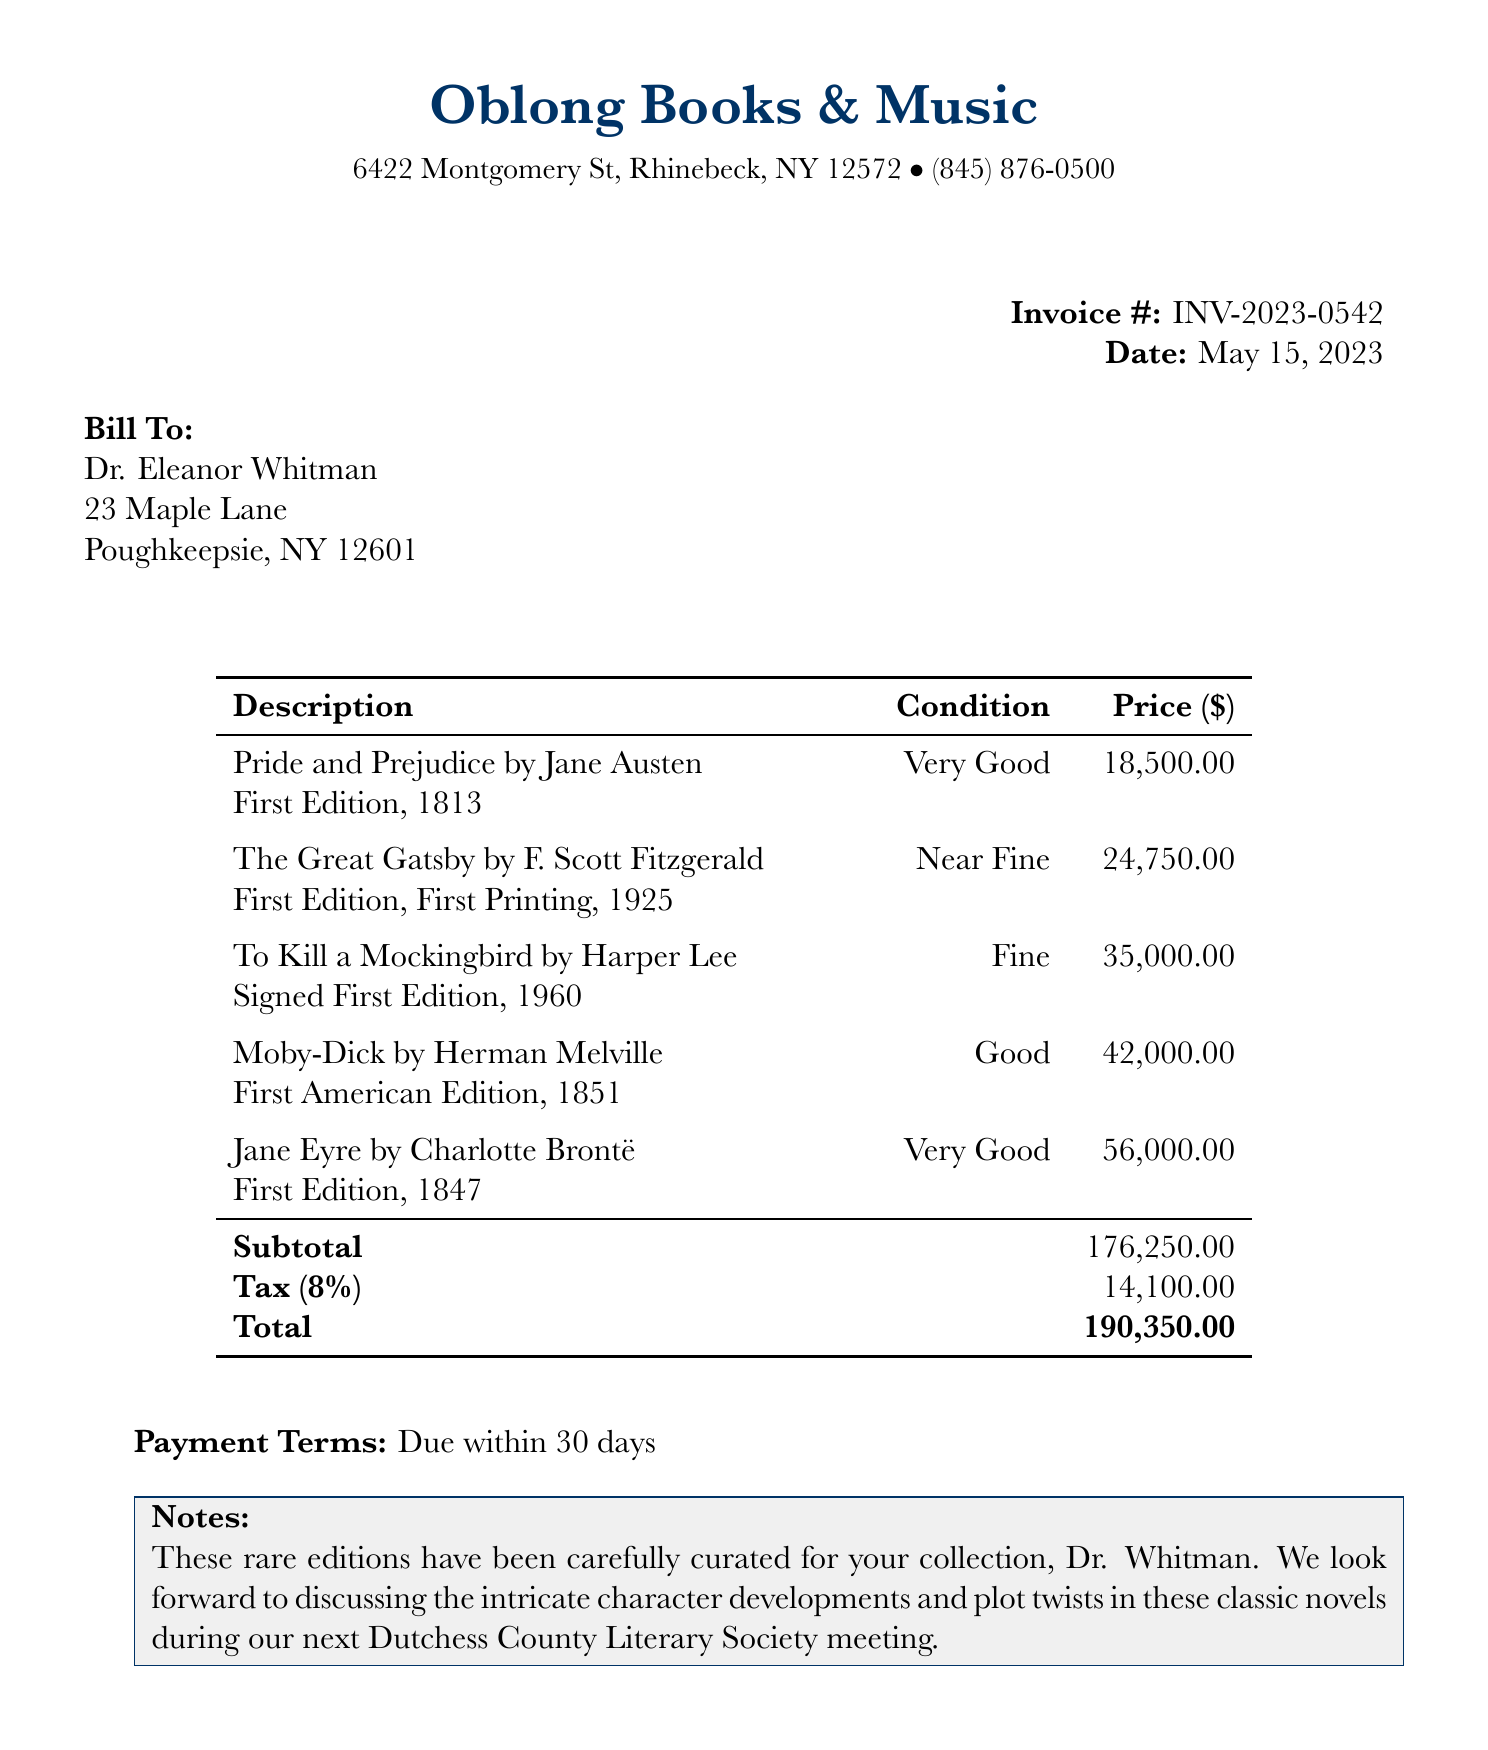What is the store's name? The store's name is listed prominently at the top of the invoice.
Answer: Oblong Books & Music Who is the customer? The customer name is mentioned in the billing section of the invoice.
Answer: Dr. Eleanor Whitman What is the total amount due? The total amount due is located at the end of the invoice after tax is added to the subtotal.
Answer: 190350.00 What is the tax rate applied? The tax rate is specified in the invoice, showing the percentage of tax imposed.
Answer: 8% How many items are listed in this invoice? The item count can be determined from the number of entries in the items table.
Answer: 5 Which book is the most expensive? The price of each book is listed, allowing identification of the highest price.
Answer: Jane Eyre What is the payment term? The payment terms are stated at the bottom of the invoice.
Answer: Due within 30 days What edition is "To Kill a Mockingbird"? The edition detail is provided in the description of the item listed on the invoice.
Answer: Signed First Edition, 1960 What notes were included with the invoice? The notes section contains additional remarks directed to the customer on the invoice.
Answer: These rare editions have been carefully curated for your collection, Dr. Whitman. We look forward to discussing the intricate character developments and plot twists in these classic novels during our next Dutchess County Literary Society meeting 